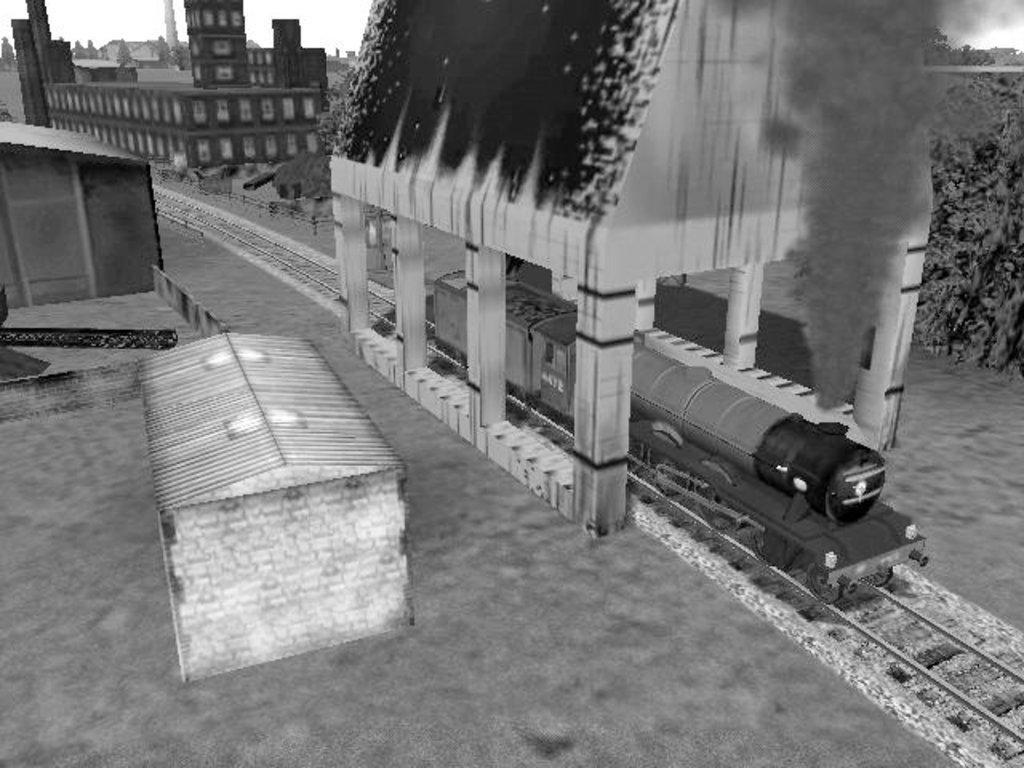What is the color scheme of the image? The image is black and white. What is the main subject of the image? There is a train in the image. What is the train doing in the image? The train is emitting smoke. What can be seen in the background of the image? There are buildings behind the train in the image. How many sisters are playing in the field in the image? There is no field or sisters present in the image; it features an animated black and white train emitting smoke with buildings in the background. 